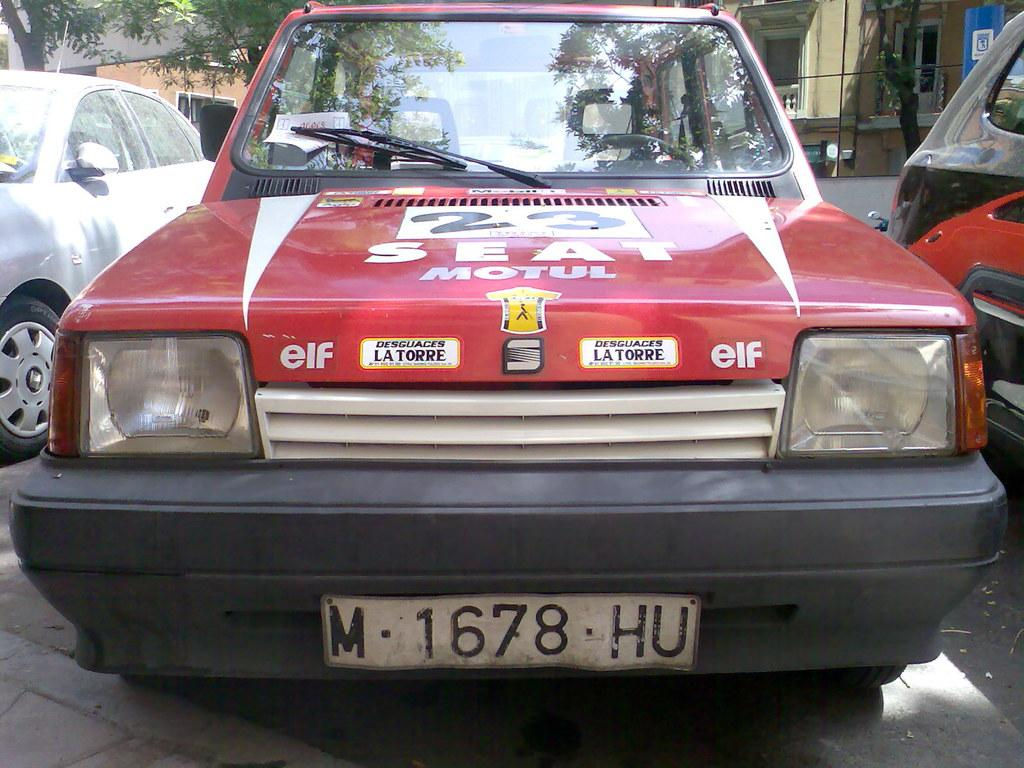What can be seen on the road in the image? There are cars on the road in the image. What is visible behind the cars? There are trees visible at the back of the cars. What type of structure is present in the image? There is a signboard in the image. What type of buildings can be seen in the image? There are buildings with windows in the image. Can you describe the unspecified objects in the image? Unfortunately, the provided facts do not specify the nature of the unspecified objects in the image. What type of cord is used to teach the cars how to drive in the image? There is no cord or teaching depicted in the image; it simply shows cars on the road with trees, a signboard, and buildings in the background. 